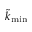<formula> <loc_0><loc_0><loc_500><loc_500>\tilde { k } _ { \min }</formula> 